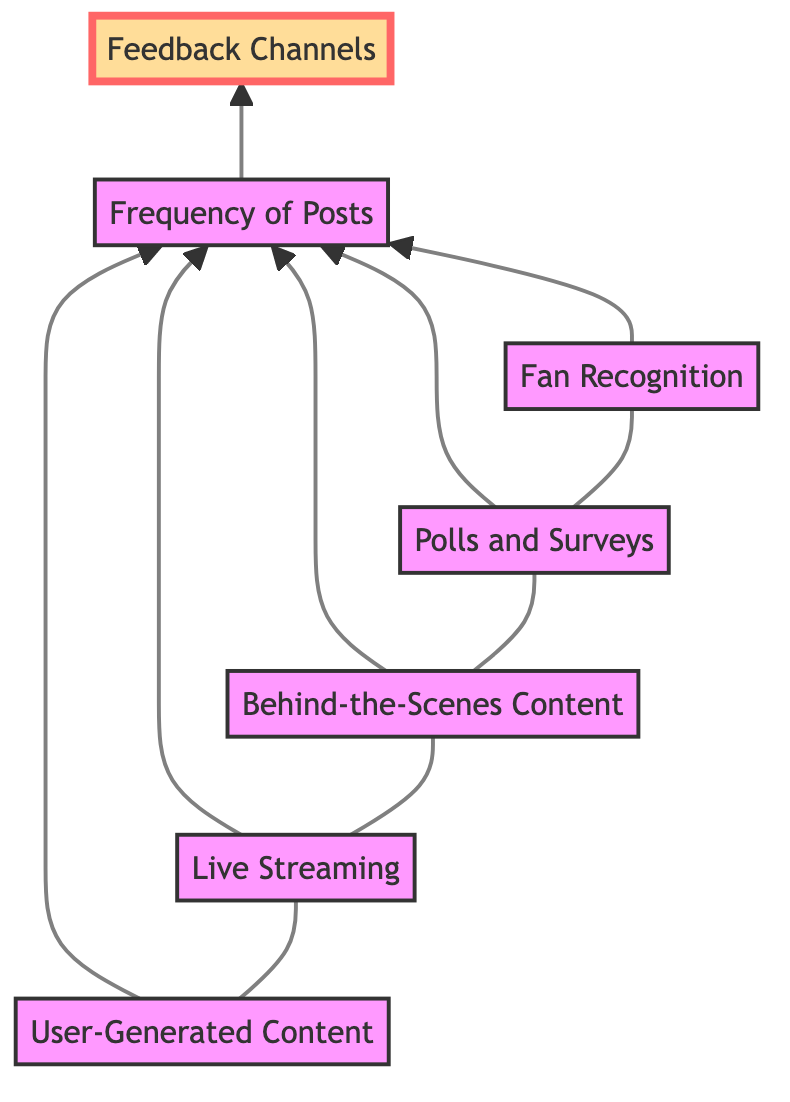What are the content types listed in the diagram? The diagram lists five content types: User-Generated Content, Live Streaming, Behind-the-Scenes Content, Polls and Surveys, and Fan Recognition.
Answer: User-Generated Content, Live Streaming, Behind-the-Scenes Content, Polls and Surveys, Fan Recognition How many nodes are connected to Frequency of Posts? The diagram shows that five nodes (User-Generated Content, Live Streaming, Behind-the-Scenes Content, Polls and Surveys, Fan Recognition) point to Frequency of Posts, indicating they are all related to it.
Answer: 5 What is the final node in the flow chart? The flow chart shows that the final node is Feedback Channels, which is connected to Frequency of Posts. This means the flow leads to this node last in the analysis.
Answer: Feedback Channels Which of the content types directly leads to Frequency of Posts? All five content types (User-Generated Content, Live Streaming, Behind-the-Scenes Content, Polls and Surveys, Fan Recognition) lead to Frequency of Posts, indicating they contribute to maintaining engagement.
Answer: All five content types What distinguishes Feedback Channels from other nodes? Feedback Channels is distinguished from the other nodes because it is the ultimate destination in the flow chart, showing it is an endpoint for the various engagement strategies discussed.
Answer: Ultimate destination Which content type involves direct interaction with fans? Live Streaming is the content type that involves direct interaction with fans through performances or Q&A sessions on social media platforms.
Answer: Live Streaming What is the relationship between Polls and Surveys and Frequency of Posts? Polls and Surveys directly contribute to Frequency of Posts by providing a way to ask fans about their preferences and keeping them engaged in the content creation process.
Answer: Direct contribution How does Fan Recognition impact social media strategy? Fan Recognition boosts fan loyalty and engagement, encouraging active participation and interaction through shoutouts and features, which influences Frequency of Posts.
Answer: Boosts fan loyalty 